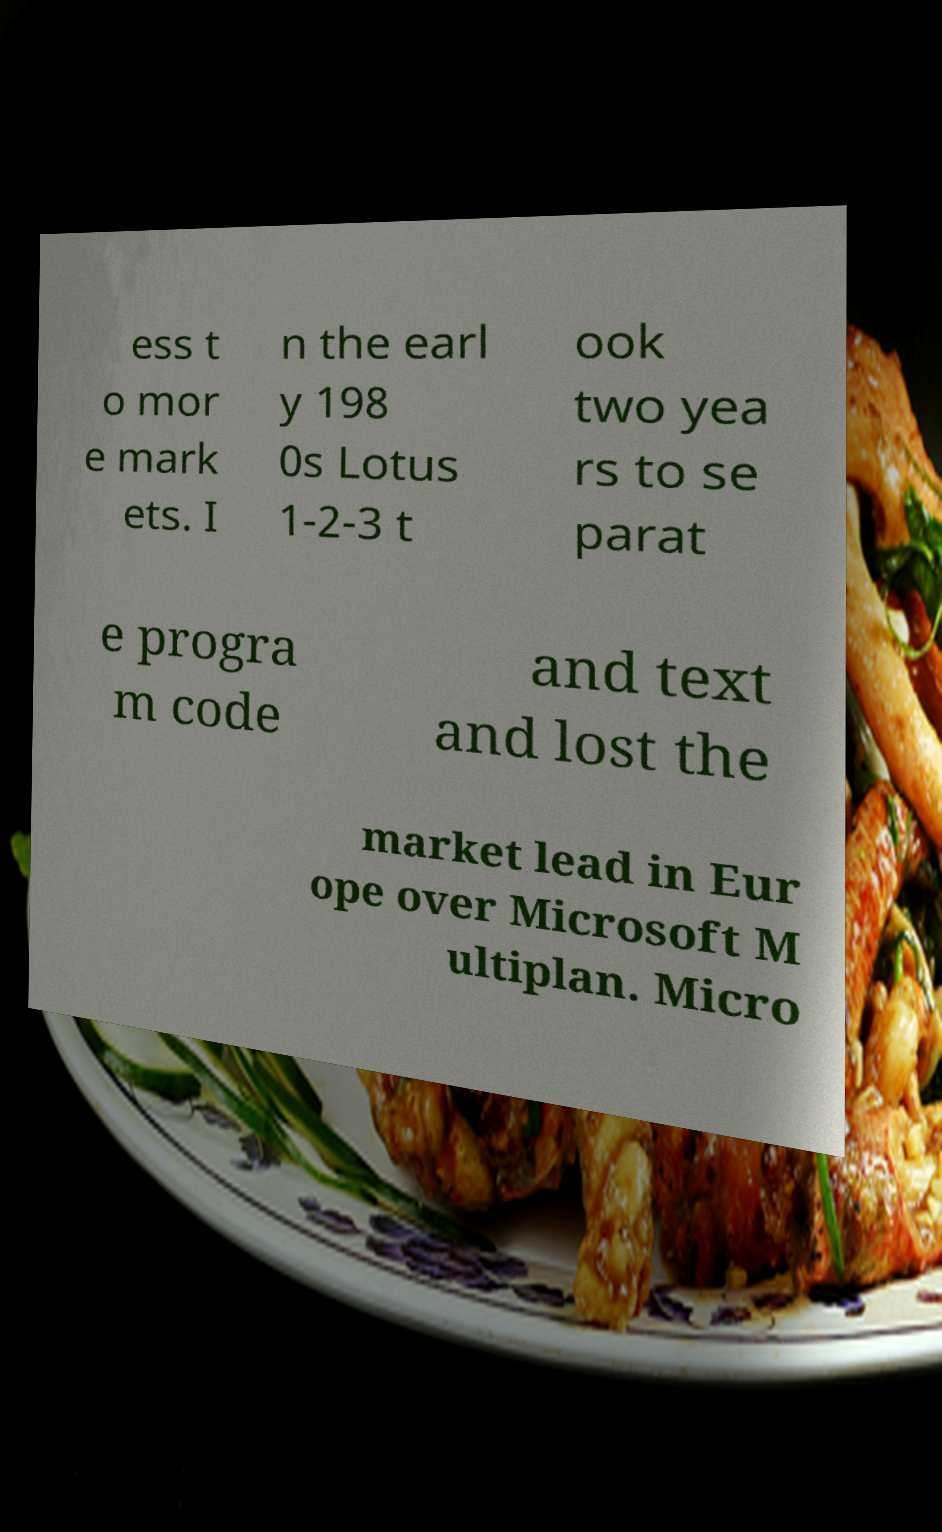I need the written content from this picture converted into text. Can you do that? ess t o mor e mark ets. I n the earl y 198 0s Lotus 1-2-3 t ook two yea rs to se parat e progra m code and text and lost the market lead in Eur ope over Microsoft M ultiplan. Micro 